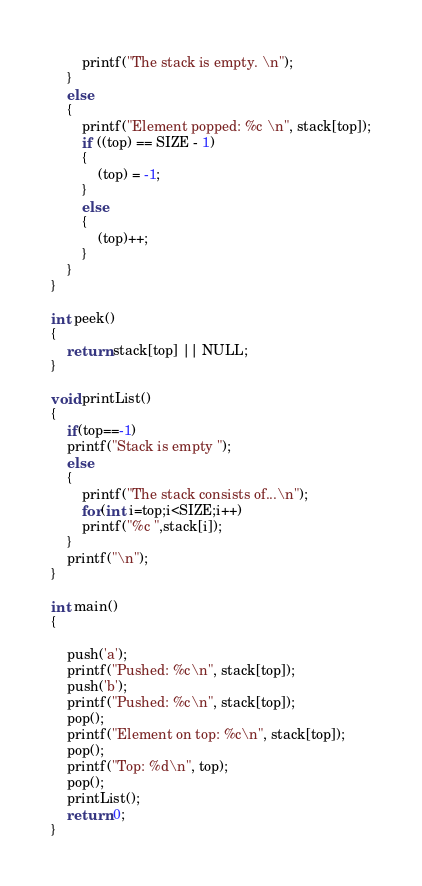Convert code to text. <code><loc_0><loc_0><loc_500><loc_500><_C_>        printf("The stack is empty. \n");
    }
    else
    {
        printf("Element popped: %c \n", stack[top]);
        if ((top) == SIZE - 1)
        {
            (top) = -1;
        }
        else
        {
            (top)++;
        }
    }
}

int peek()
{
    return stack[top] || NULL;
}

void printList()
{
    if(top==-1)
    printf("Stack is empty ");
    else
    {
        printf("The stack consists of...\n");
        for(int i=top;i<SIZE;i++)
        printf("%c ",stack[i]);
    }
    printf("\n");
}

int main()
{

    push('a');
    printf("Pushed: %c\n", stack[top]);
    push('b');
    printf("Pushed: %c\n", stack[top]);
    pop();
    printf("Element on top: %c\n", stack[top]);
    pop();
    printf("Top: %d\n", top);
    pop();
    printList();
    return 0;
}</code> 